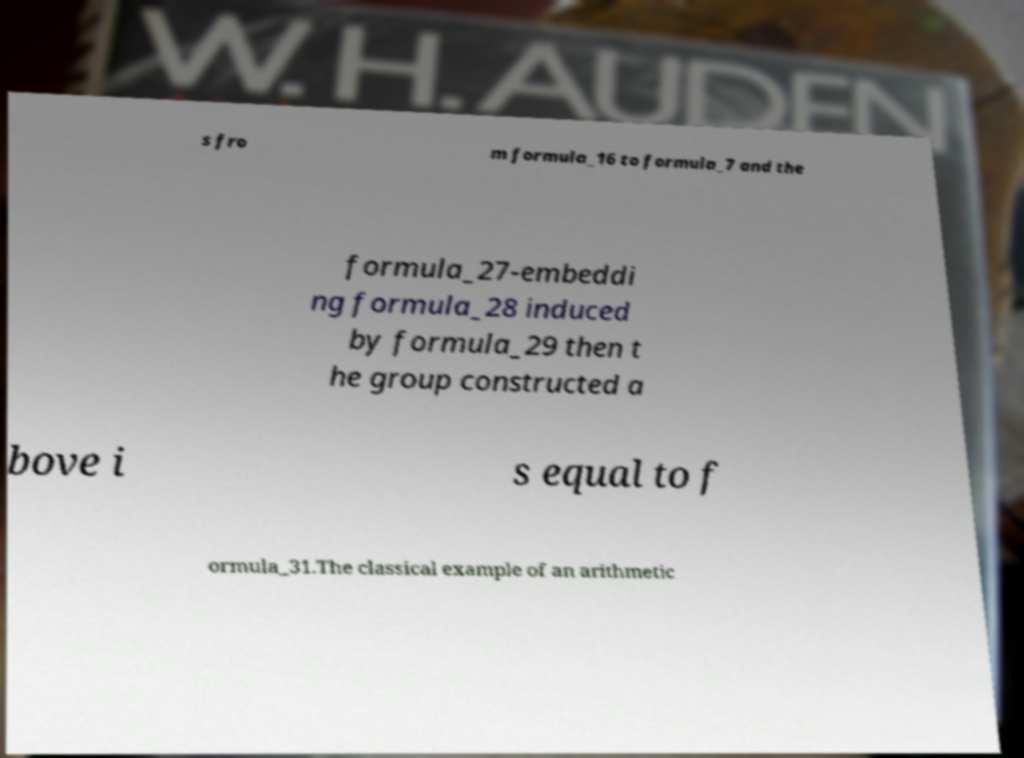For documentation purposes, I need the text within this image transcribed. Could you provide that? s fro m formula_16 to formula_7 and the formula_27-embeddi ng formula_28 induced by formula_29 then t he group constructed a bove i s equal to f ormula_31.The classical example of an arithmetic 